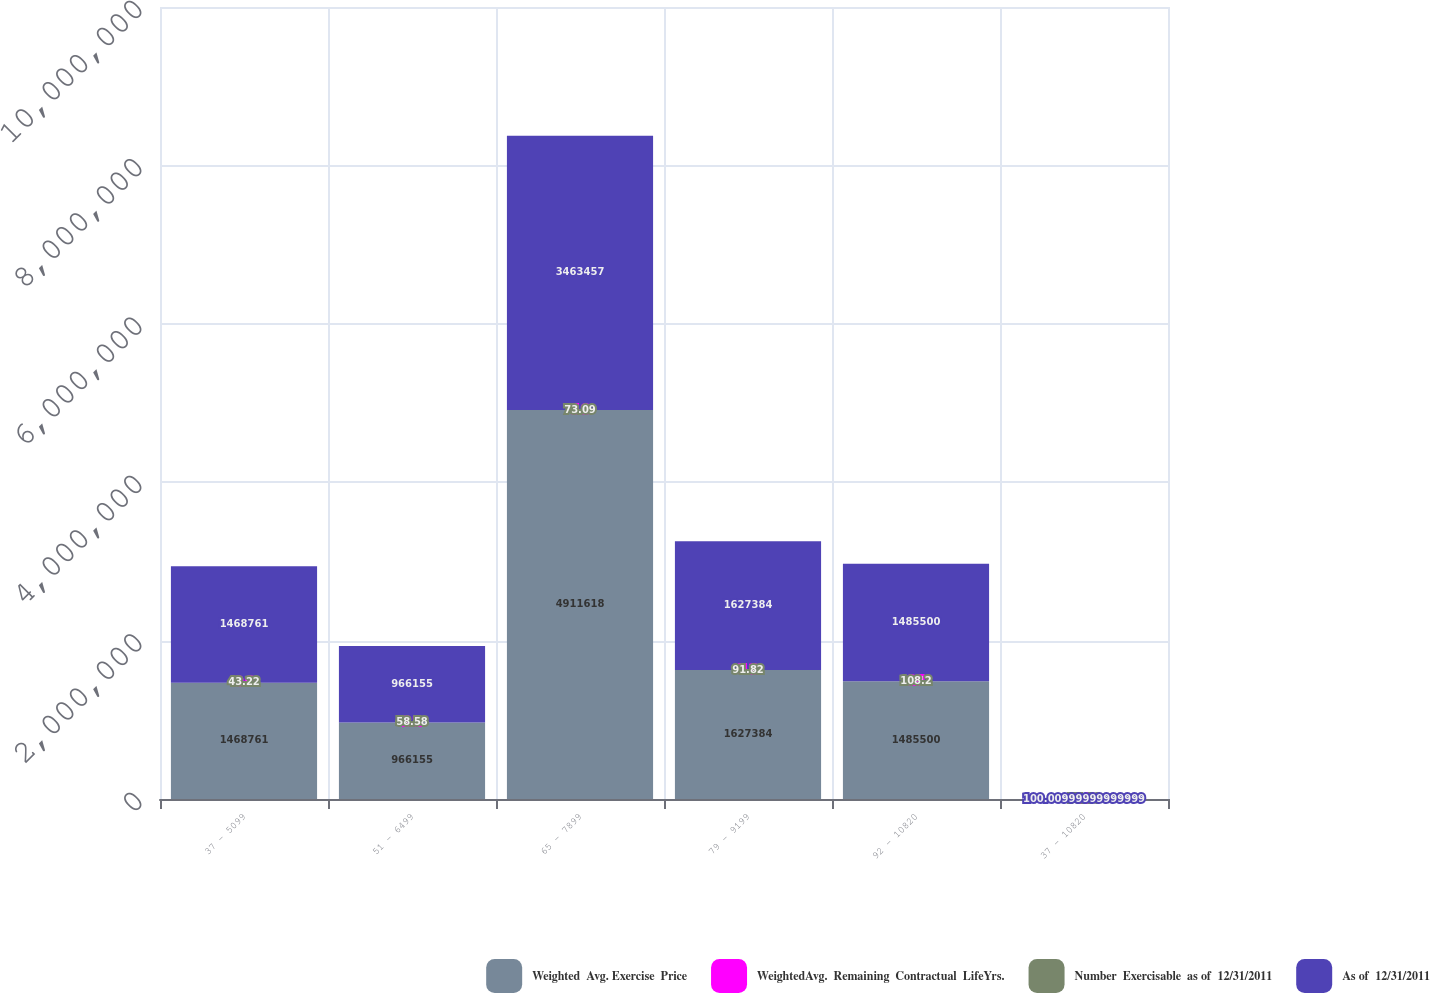Convert chart. <chart><loc_0><loc_0><loc_500><loc_500><stacked_bar_chart><ecel><fcel>37 - 5099<fcel>51 - 6499<fcel>65 - 7899<fcel>79 - 9199<fcel>92 - 10820<fcel>37 - 10820<nl><fcel>Weighted  Avg. Exercise  Price<fcel>1.46876e+06<fcel>966155<fcel>4.91162e+06<fcel>1.62738e+06<fcel>1.4855e+06<fcel>100.01<nl><fcel>WeightedAvg.  Remaining  Contractual  LifeYrs.<fcel>0.6<fcel>2.2<fcel>5.8<fcel>5.1<fcel>6.1<fcel>4.7<nl><fcel>Number  Exercisable  as of  12/31/2011<fcel>43.22<fcel>58.58<fcel>73.09<fcel>91.82<fcel>108.2<fcel>75.46<nl><fcel>As of  12/31/2011<fcel>1.46876e+06<fcel>966155<fcel>3.46346e+06<fcel>1.62738e+06<fcel>1.4855e+06<fcel>100.01<nl></chart> 